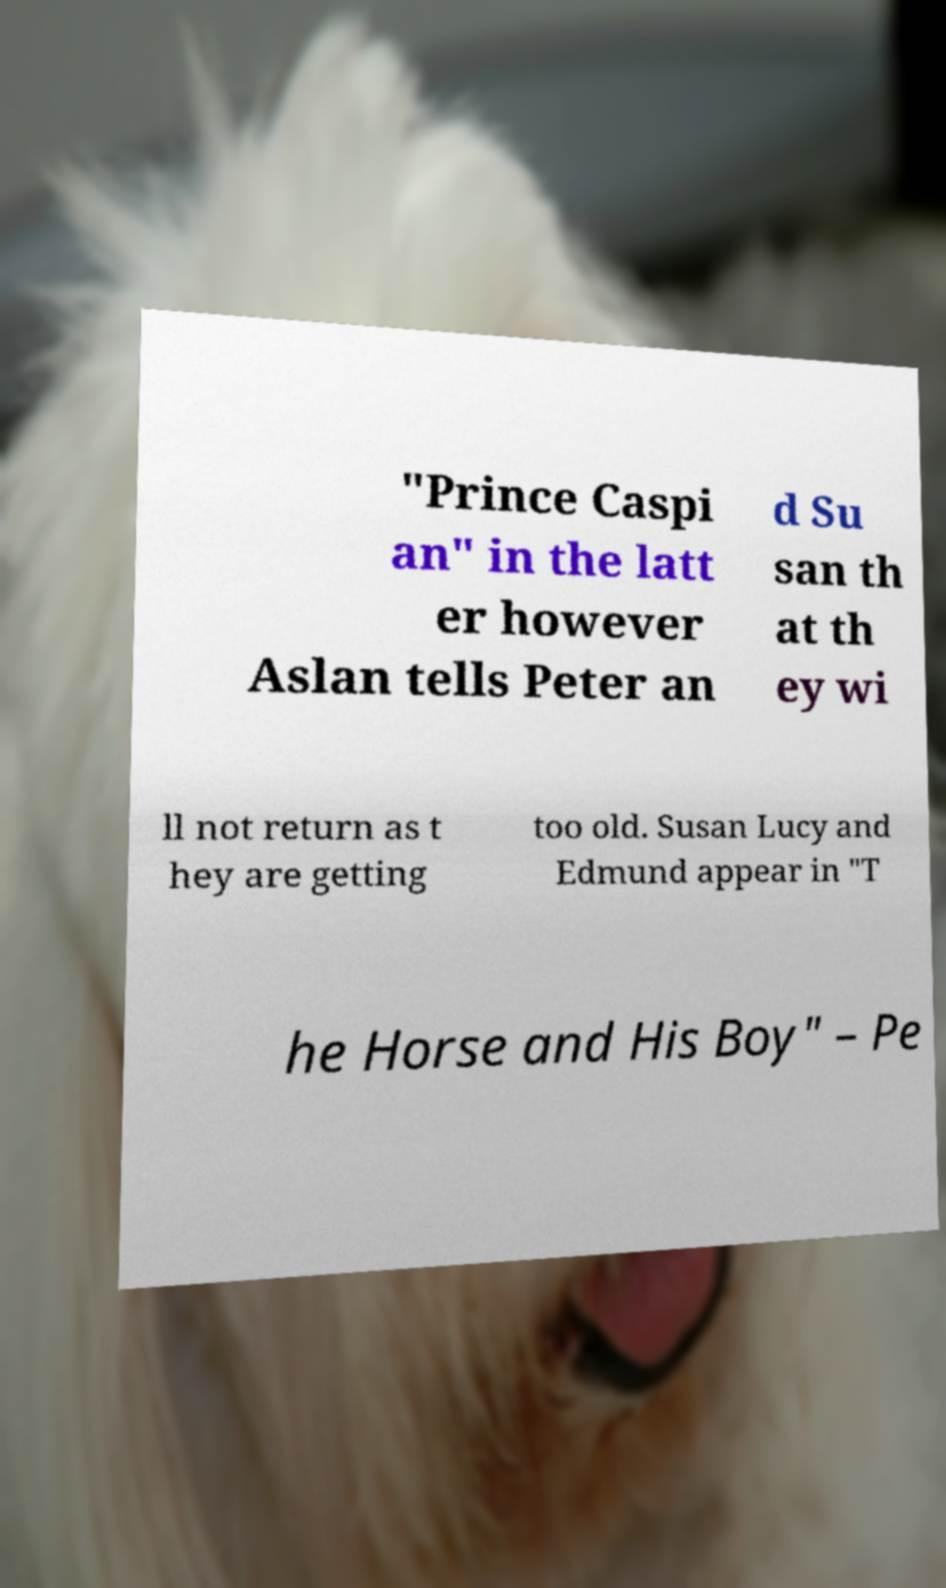Could you extract and type out the text from this image? "Prince Caspi an" in the latt er however Aslan tells Peter an d Su san th at th ey wi ll not return as t hey are getting too old. Susan Lucy and Edmund appear in "T he Horse and His Boy" – Pe 